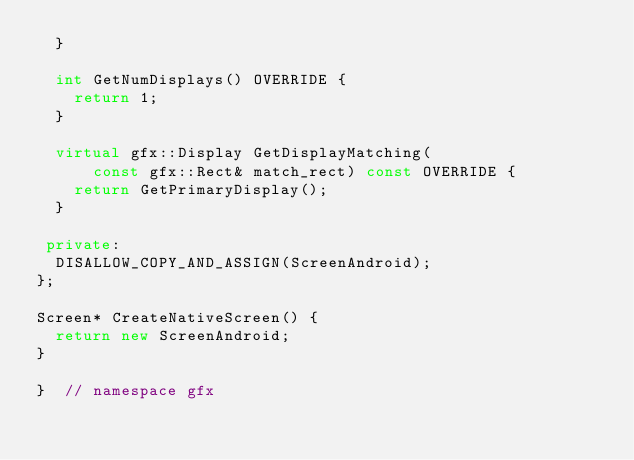<code> <loc_0><loc_0><loc_500><loc_500><_C++_>  }

  int GetNumDisplays() OVERRIDE {
    return 1;
  }

  virtual gfx::Display GetDisplayMatching(
      const gfx::Rect& match_rect) const OVERRIDE {
    return GetPrimaryDisplay();
  }

 private:
  DISALLOW_COPY_AND_ASSIGN(ScreenAndroid);
};

Screen* CreateNativeScreen() {
  return new ScreenAndroid;
}

}  // namespace gfx
</code> 